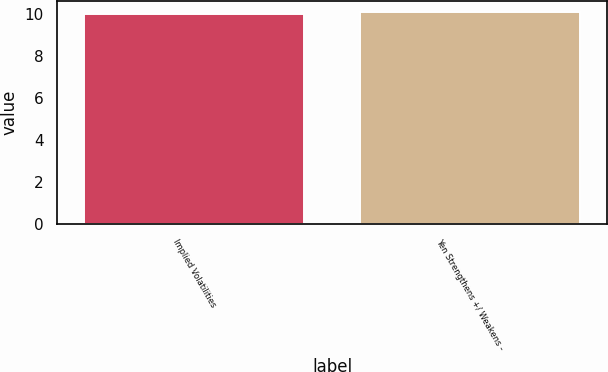<chart> <loc_0><loc_0><loc_500><loc_500><bar_chart><fcel>Implied Volatilities<fcel>Yen Strengthens +/ Weakens -<nl><fcel>10<fcel>10.1<nl></chart> 